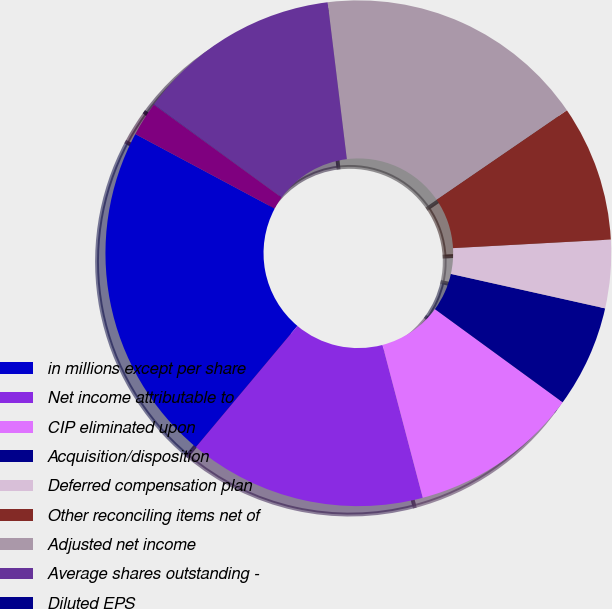Convert chart to OTSL. <chart><loc_0><loc_0><loc_500><loc_500><pie_chart><fcel>in millions except per share<fcel>Net income attributable to<fcel>CIP eliminated upon<fcel>Acquisition/disposition<fcel>Deferred compensation plan<fcel>Other reconciling items net of<fcel>Adjusted net income<fcel>Average shares outstanding -<fcel>Diluted EPS<fcel>Adjusted diluted EPS<nl><fcel>21.71%<fcel>15.2%<fcel>10.87%<fcel>6.53%<fcel>4.36%<fcel>8.7%<fcel>17.37%<fcel>13.04%<fcel>0.02%<fcel>2.19%<nl></chart> 